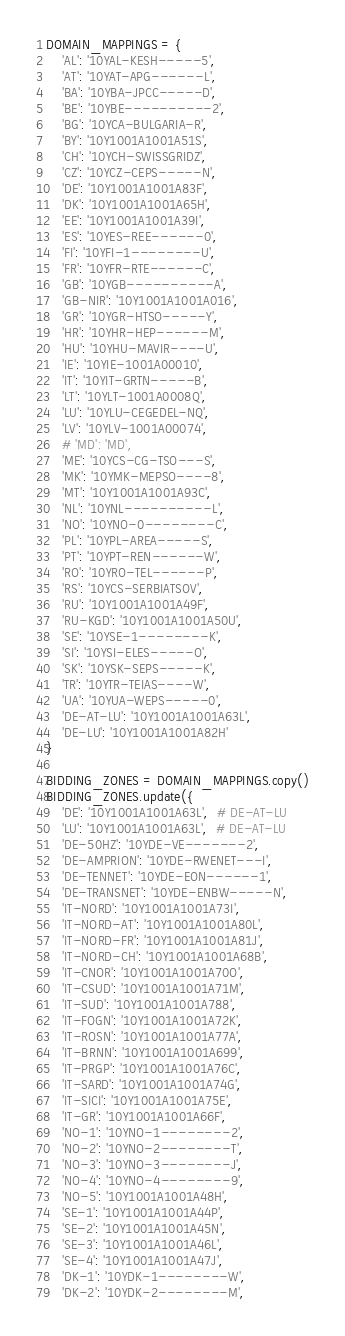Convert code to text. <code><loc_0><loc_0><loc_500><loc_500><_Python_>DOMAIN_MAPPINGS = {
    'AL': '10YAL-KESH-----5',
    'AT': '10YAT-APG------L',
    'BA': '10YBA-JPCC-----D',
    'BE': '10YBE----------2',
    'BG': '10YCA-BULGARIA-R',
    'BY': '10Y1001A1001A51S',
    'CH': '10YCH-SWISSGRIDZ',
    'CZ': '10YCZ-CEPS-----N',
    'DE': '10Y1001A1001A83F',
    'DK': '10Y1001A1001A65H',
    'EE': '10Y1001A1001A39I',
    'ES': '10YES-REE------0',
    'FI': '10YFI-1--------U',
    'FR': '10YFR-RTE------C',
    'GB': '10YGB----------A',
    'GB-NIR': '10Y1001A1001A016',
    'GR': '10YGR-HTSO-----Y',
    'HR': '10YHR-HEP------M',
    'HU': '10YHU-MAVIR----U',
    'IE': '10YIE-1001A00010',
    'IT': '10YIT-GRTN-----B',
    'LT': '10YLT-1001A0008Q',
    'LU': '10YLU-CEGEDEL-NQ',
    'LV': '10YLV-1001A00074',
    # 'MD': 'MD',
    'ME': '10YCS-CG-TSO---S',
    'MK': '10YMK-MEPSO----8',
    'MT': '10Y1001A1001A93C',
    'NL': '10YNL----------L',
    'NO': '10YNO-0--------C',
    'PL': '10YPL-AREA-----S',
    'PT': '10YPT-REN------W',
    'RO': '10YRO-TEL------P',
    'RS': '10YCS-SERBIATSOV',
    'RU': '10Y1001A1001A49F',
    'RU-KGD': '10Y1001A1001A50U',
    'SE': '10YSE-1--------K',
    'SI': '10YSI-ELES-----O',
    'SK': '10YSK-SEPS-----K',
    'TR': '10YTR-TEIAS----W',
    'UA': '10YUA-WEPS-----0',
    'DE-AT-LU': '10Y1001A1001A63L',
    'DE-LU': '10Y1001A1001A82H'
}

BIDDING_ZONES = DOMAIN_MAPPINGS.copy()
BIDDING_ZONES.update({
    'DE': '10Y1001A1001A63L',  # DE-AT-LU
    'LU': '10Y1001A1001A63L',  # DE-AT-LU
    'DE-50HZ': '10YDE-VE-------2',
    'DE-AMPRION': '10YDE-RWENET---I',
    'DE-TENNET': '10YDE-EON------1',
    'DE-TRANSNET': '10YDE-ENBW-----N',
    'IT-NORD': '10Y1001A1001A73I',
    'IT-NORD-AT': '10Y1001A1001A80L',
    'IT-NORD-FR': '10Y1001A1001A81J',
    'IT-NORD-CH': '10Y1001A1001A68B',
    'IT-CNOR': '10Y1001A1001A70O',
    'IT-CSUD': '10Y1001A1001A71M',
    'IT-SUD': '10Y1001A1001A788',
    'IT-FOGN': '10Y1001A1001A72K',
    'IT-ROSN': '10Y1001A1001A77A',
    'IT-BRNN': '10Y1001A1001A699',
    'IT-PRGP': '10Y1001A1001A76C',
    'IT-SARD': '10Y1001A1001A74G',
    'IT-SICI': '10Y1001A1001A75E',
    'IT-GR': '10Y1001A1001A66F',
    'NO-1': '10YNO-1--------2',
    'NO-2': '10YNO-2--------T',
    'NO-3': '10YNO-3--------J',
    'NO-4': '10YNO-4--------9',
    'NO-5': '10Y1001A1001A48H',
    'SE-1': '10Y1001A1001A44P',
    'SE-2': '10Y1001A1001A45N',
    'SE-3': '10Y1001A1001A46L',
    'SE-4': '10Y1001A1001A47J',
    'DK-1': '10YDK-1--------W',
    'DK-2': '10YDK-2--------M',</code> 